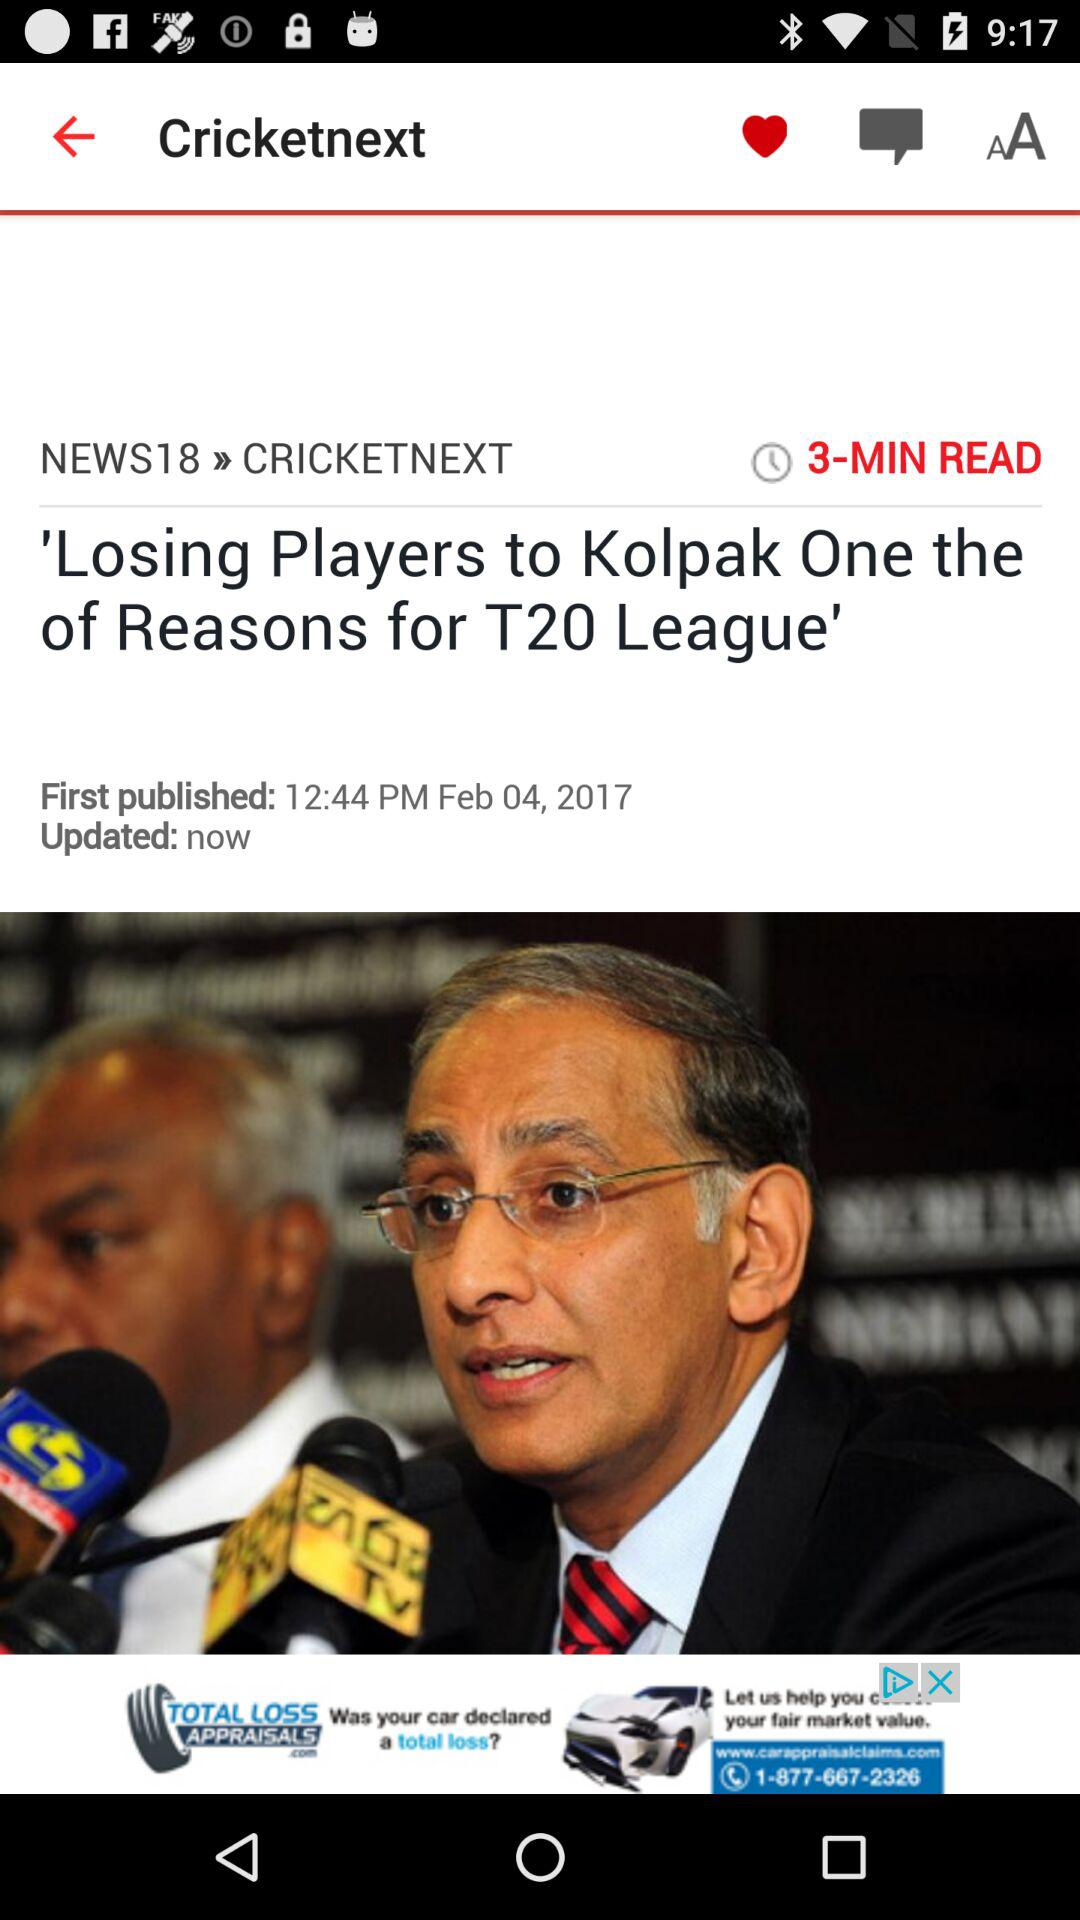When was the news last updated? The new was last updated just now. 